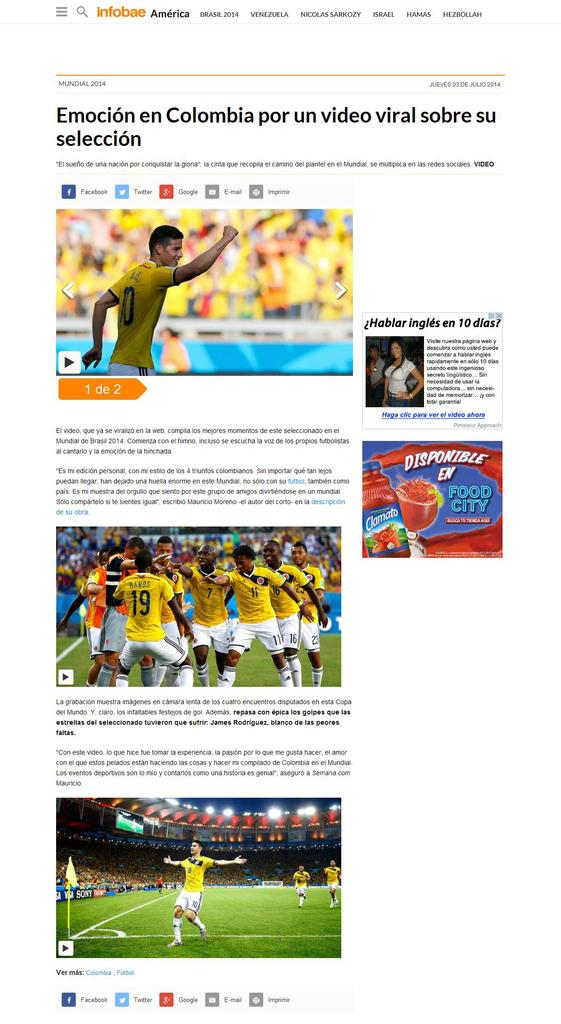<image>
Provide a brief description of the given image. A webpage reading Emocion en Colombia por un video viral sobre su seleccion. 